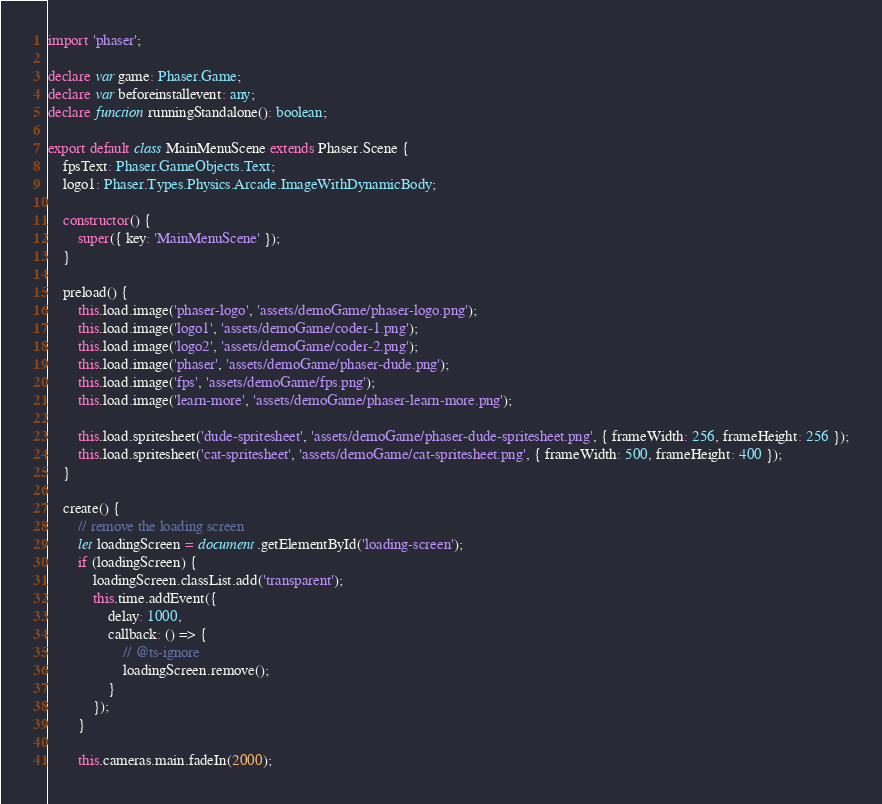<code> <loc_0><loc_0><loc_500><loc_500><_TypeScript_>import 'phaser';

declare var game: Phaser.Game;
declare var beforeinstallevent: any;
declare function runningStandalone(): boolean;

export default class MainMenuScene extends Phaser.Scene {
    fpsText: Phaser.GameObjects.Text;
    logo1: Phaser.Types.Physics.Arcade.ImageWithDynamicBody;

    constructor() {
        super({ key: 'MainMenuScene' });
    }

    preload() {
        this.load.image('phaser-logo', 'assets/demoGame/phaser-logo.png');
        this.load.image('logo1', 'assets/demoGame/coder-1.png');
        this.load.image('logo2', 'assets/demoGame/coder-2.png');
        this.load.image('phaser', 'assets/demoGame/phaser-dude.png');
        this.load.image('fps', 'assets/demoGame/fps.png');
        this.load.image('learn-more', 'assets/demoGame/phaser-learn-more.png');

        this.load.spritesheet('dude-spritesheet', 'assets/demoGame/phaser-dude-spritesheet.png', { frameWidth: 256, frameHeight: 256 });
        this.load.spritesheet('cat-spritesheet', 'assets/demoGame/cat-spritesheet.png', { frameWidth: 500, frameHeight: 400 });
    }

    create() {
        // remove the loading screen
        let loadingScreen = document.getElementById('loading-screen');
        if (loadingScreen) {
            loadingScreen.classList.add('transparent');
            this.time.addEvent({
                delay: 1000,
                callback: () => {
                    // @ts-ignore
                    loadingScreen.remove();
                }
            });
        }

        this.cameras.main.fadeIn(2000);</code> 